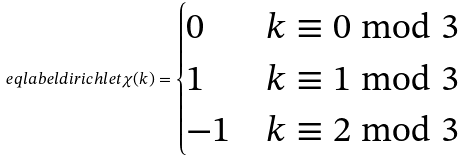Convert formula to latex. <formula><loc_0><loc_0><loc_500><loc_500>\ e q l a b e l { d i r i c h l e t } \chi ( k ) = \begin{cases} 0 & k \equiv 0 \bmod 3 \\ 1 & k \equiv 1 \bmod 3 \\ - 1 & k \equiv 2 \bmod 3 \end{cases}</formula> 